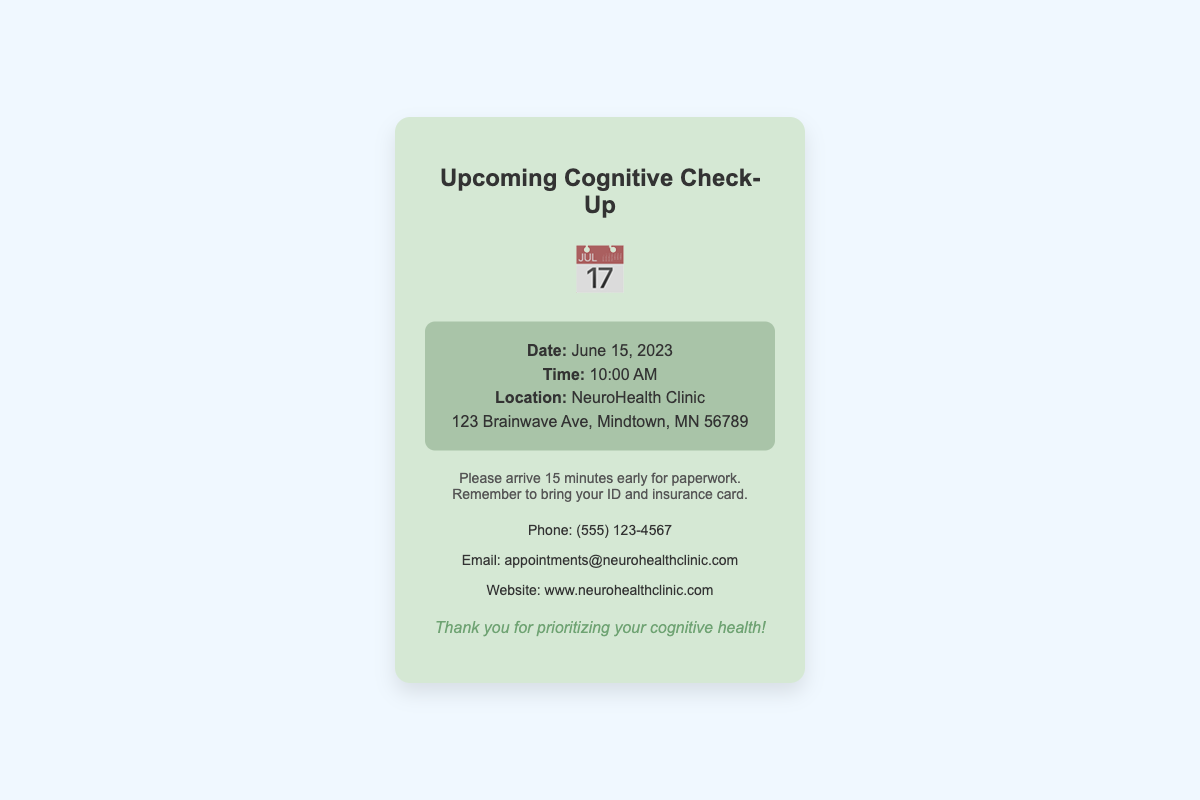what is the date of the appointment? The date of the appointment is mentioned in the document, specifically stating "June 15, 2023."
Answer: June 15, 2023 what time is the appointment scheduled for? The document clearly indicates "10:00 AM" as the time for the appointment.
Answer: 10:00 AM where will the cognitive check-up take place? The location is specified in the document as "NeuroHealth Clinic."
Answer: NeuroHealth Clinic what is the address of the appointment location? The complete address is provided in the document as "123 Brainwave Ave, Mindtown, MN 56789."
Answer: 123 Brainwave Ave, Mindtown, MN 56789 how early should the patient arrive? The document advises to "arrive 15 minutes early for paperwork."
Answer: 15 minutes what should be brought to the appointment? The notes section indicates the patient should "bring your ID and insurance card."
Answer: ID and insurance card what icon is displayed on the card? The card features a calendar icon represented by "📅."
Answer: 📅 how can one contact the clinic by phone? The contact information specifies the phone number as "(555) 123-4567."
Answer: (555) 123-4567 what type of document is this? This document serves as a reminder card for a cognitive check-up appointment.
Answer: reminder card 